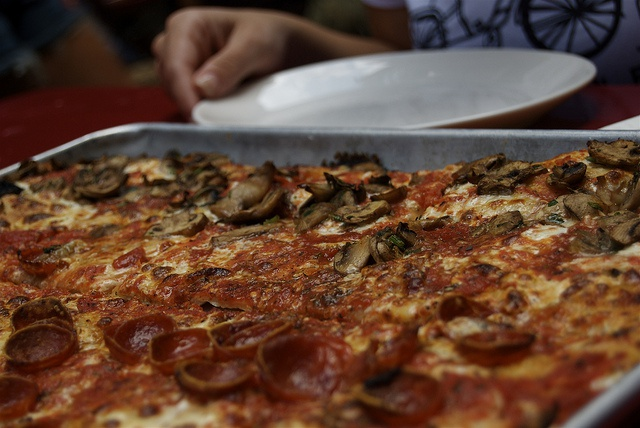Describe the objects in this image and their specific colors. I can see dining table in maroon, black, brown, and darkgray tones, pizza in black, maroon, and brown tones, and people in black, maroon, and gray tones in this image. 